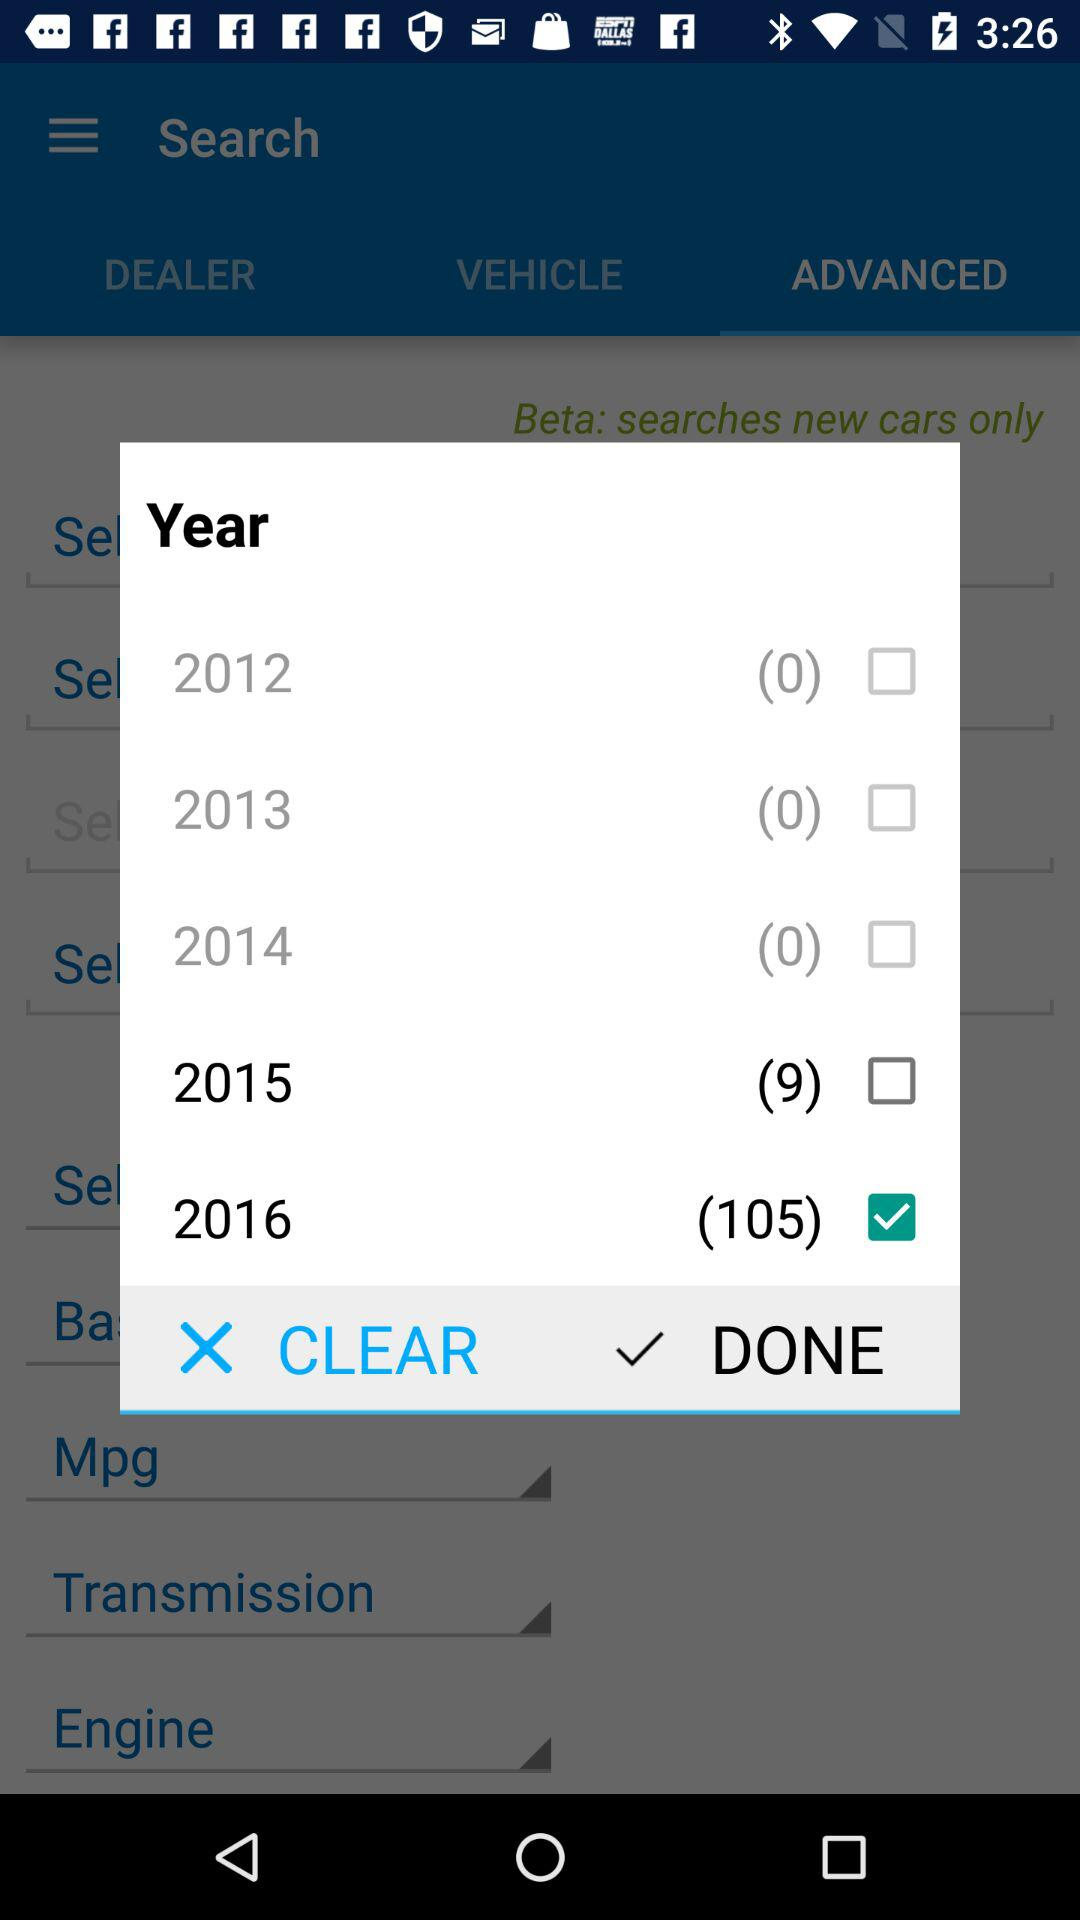What is the current status of "2012"? The current status of "2012" is "off". 